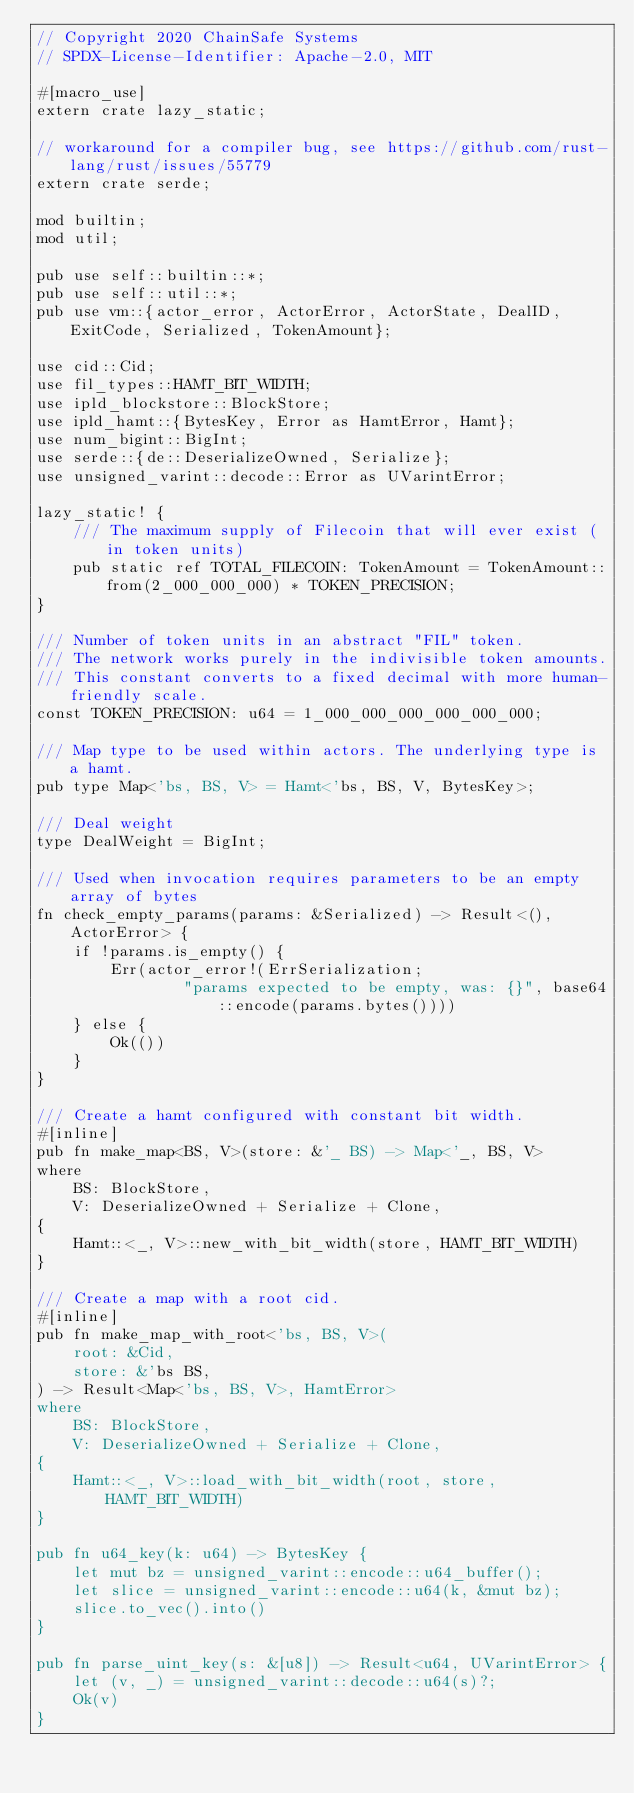<code> <loc_0><loc_0><loc_500><loc_500><_Rust_>// Copyright 2020 ChainSafe Systems
// SPDX-License-Identifier: Apache-2.0, MIT

#[macro_use]
extern crate lazy_static;

// workaround for a compiler bug, see https://github.com/rust-lang/rust/issues/55779
extern crate serde;

mod builtin;
mod util;

pub use self::builtin::*;
pub use self::util::*;
pub use vm::{actor_error, ActorError, ActorState, DealID, ExitCode, Serialized, TokenAmount};

use cid::Cid;
use fil_types::HAMT_BIT_WIDTH;
use ipld_blockstore::BlockStore;
use ipld_hamt::{BytesKey, Error as HamtError, Hamt};
use num_bigint::BigInt;
use serde::{de::DeserializeOwned, Serialize};
use unsigned_varint::decode::Error as UVarintError;

lazy_static! {
    /// The maximum supply of Filecoin that will ever exist (in token units)
    pub static ref TOTAL_FILECOIN: TokenAmount = TokenAmount::from(2_000_000_000) * TOKEN_PRECISION;
}

/// Number of token units in an abstract "FIL" token.
/// The network works purely in the indivisible token amounts.
/// This constant converts to a fixed decimal with more human-friendly scale.
const TOKEN_PRECISION: u64 = 1_000_000_000_000_000_000;

/// Map type to be used within actors. The underlying type is a hamt.
pub type Map<'bs, BS, V> = Hamt<'bs, BS, V, BytesKey>;

/// Deal weight
type DealWeight = BigInt;

/// Used when invocation requires parameters to be an empty array of bytes
fn check_empty_params(params: &Serialized) -> Result<(), ActorError> {
    if !params.is_empty() {
        Err(actor_error!(ErrSerialization;
                "params expected to be empty, was: {}", base64::encode(params.bytes())))
    } else {
        Ok(())
    }
}

/// Create a hamt configured with constant bit width.
#[inline]
pub fn make_map<BS, V>(store: &'_ BS) -> Map<'_, BS, V>
where
    BS: BlockStore,
    V: DeserializeOwned + Serialize + Clone,
{
    Hamt::<_, V>::new_with_bit_width(store, HAMT_BIT_WIDTH)
}

/// Create a map with a root cid.
#[inline]
pub fn make_map_with_root<'bs, BS, V>(
    root: &Cid,
    store: &'bs BS,
) -> Result<Map<'bs, BS, V>, HamtError>
where
    BS: BlockStore,
    V: DeserializeOwned + Serialize + Clone,
{
    Hamt::<_, V>::load_with_bit_width(root, store, HAMT_BIT_WIDTH)
}

pub fn u64_key(k: u64) -> BytesKey {
    let mut bz = unsigned_varint::encode::u64_buffer();
    let slice = unsigned_varint::encode::u64(k, &mut bz);
    slice.to_vec().into()
}

pub fn parse_uint_key(s: &[u8]) -> Result<u64, UVarintError> {
    let (v, _) = unsigned_varint::decode::u64(s)?;
    Ok(v)
}
</code> 